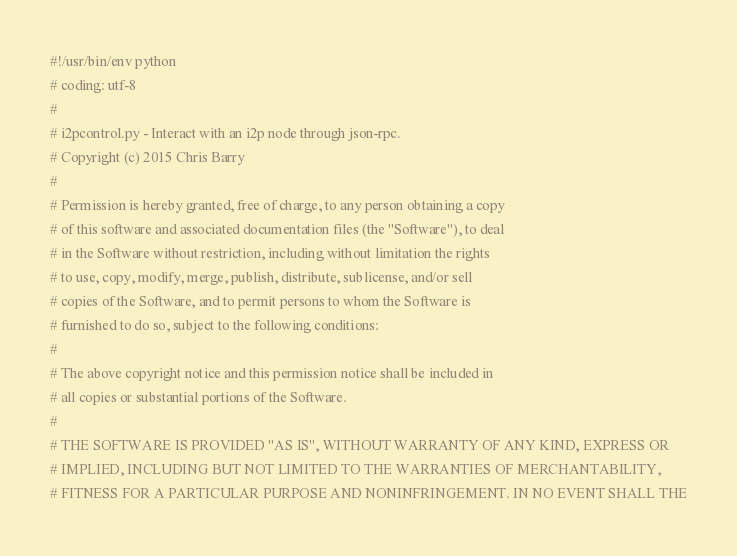<code> <loc_0><loc_0><loc_500><loc_500><_Python_>#!/usr/bin/env python
# coding: utf-8
#
# i2pcontrol.py - Interact with an i2p node through json-rpc.
# Copyright (c) 2015 Chris Barry
# 
# Permission is hereby granted, free of charge, to any person obtaining a copy
# of this software and associated documentation files (the "Software"), to deal
# in the Software without restriction, including without limitation the rights
# to use, copy, modify, merge, publish, distribute, sublicense, and/or sell
# copies of the Software, and to permit persons to whom the Software is
# furnished to do so, subject to the following conditions:
# 
# The above copyright notice and this permission notice shall be included in
# all copies or substantial portions of the Software.
# 
# THE SOFTWARE IS PROVIDED "AS IS", WITHOUT WARRANTY OF ANY KIND, EXPRESS OR
# IMPLIED, INCLUDING BUT NOT LIMITED TO THE WARRANTIES OF MERCHANTABILITY,
# FITNESS FOR A PARTICULAR PURPOSE AND NONINFRINGEMENT. IN NO EVENT SHALL THE</code> 